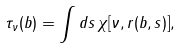<formula> <loc_0><loc_0><loc_500><loc_500>\tau _ { \nu } ( b ) = \int d s \, \chi [ \nu , r ( b , s ) ] ,</formula> 